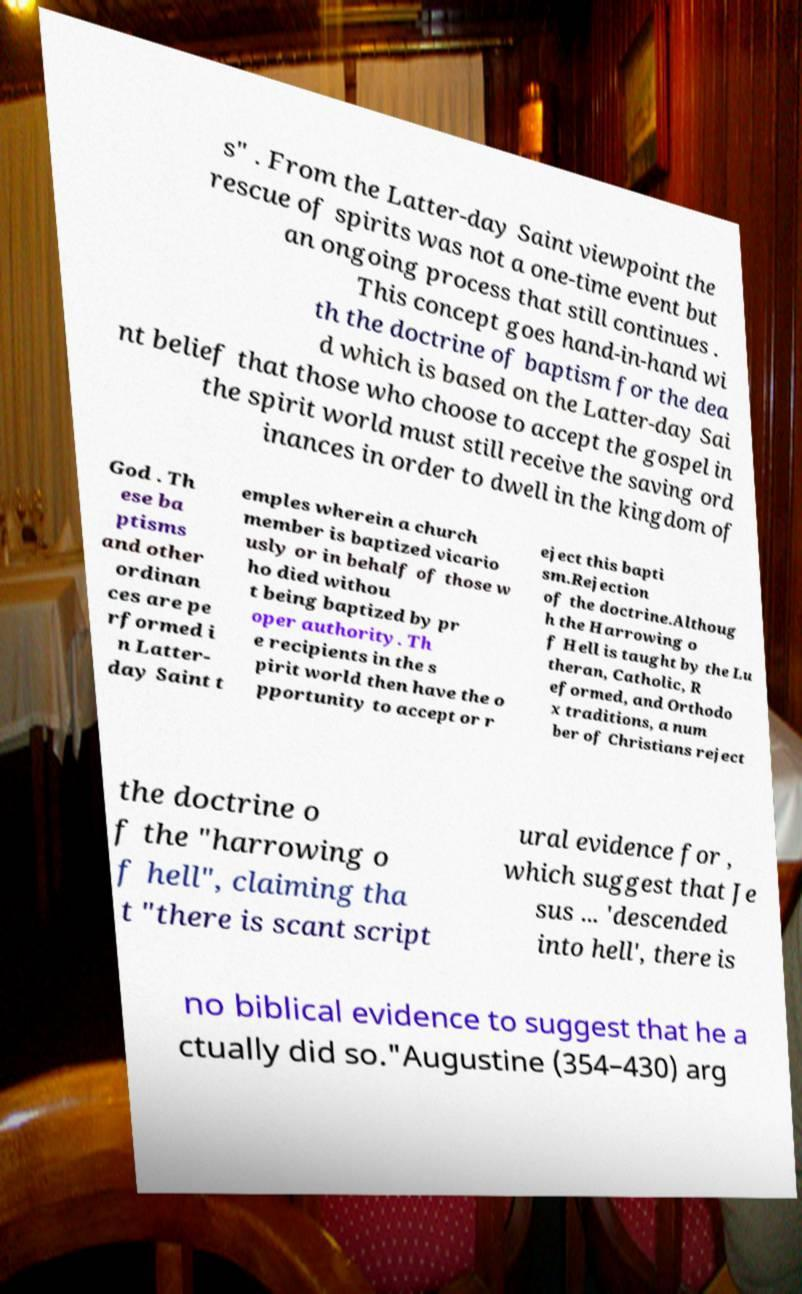Could you assist in decoding the text presented in this image and type it out clearly? s" . From the Latter-day Saint viewpoint the rescue of spirits was not a one-time event but an ongoing process that still continues . This concept goes hand-in-hand wi th the doctrine of baptism for the dea d which is based on the Latter-day Sai nt belief that those who choose to accept the gospel in the spirit world must still receive the saving ord inances in order to dwell in the kingdom of God . Th ese ba ptisms and other ordinan ces are pe rformed i n Latter- day Saint t emples wherein a church member is baptized vicario usly or in behalf of those w ho died withou t being baptized by pr oper authority. Th e recipients in the s pirit world then have the o pportunity to accept or r eject this bapti sm.Rejection of the doctrine.Althoug h the Harrowing o f Hell is taught by the Lu theran, Catholic, R eformed, and Orthodo x traditions, a num ber of Christians reject the doctrine o f the "harrowing o f hell", claiming tha t "there is scant script ural evidence for , which suggest that Je sus ... 'descended into hell', there is no biblical evidence to suggest that he a ctually did so."Augustine (354–430) arg 